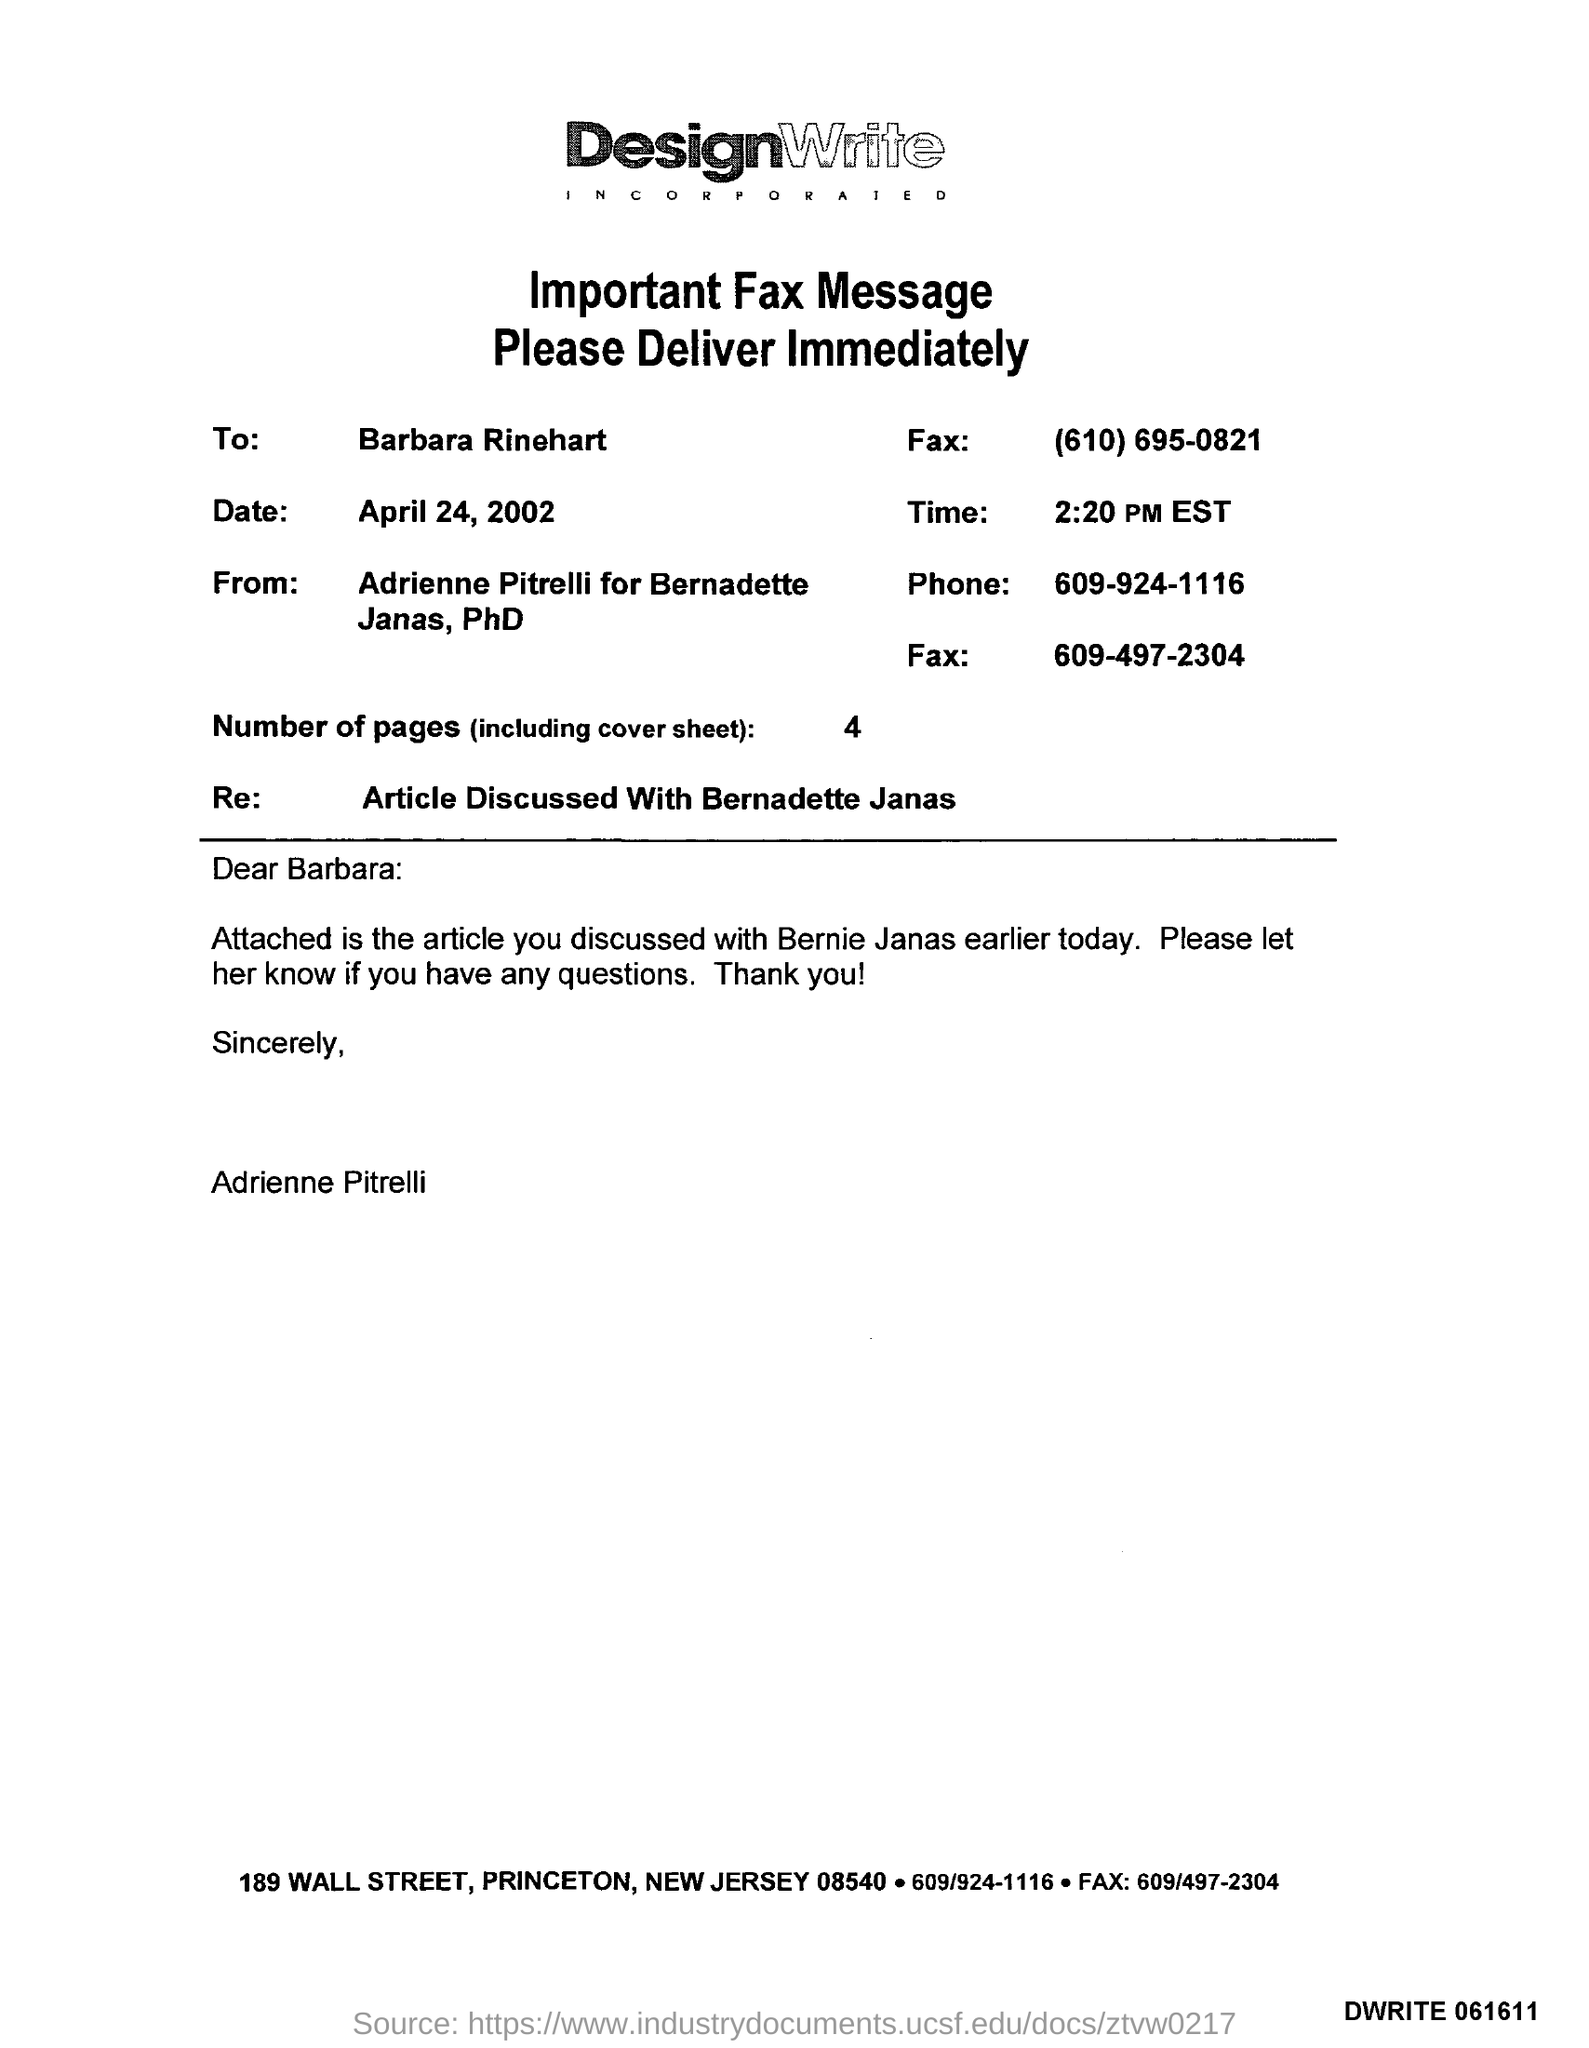Which company's fax message is this?
Your response must be concise. DesignWrite. To whom, the Fax is being sent?
Your answer should be compact. Barbara Rinehart. What is the date mentioned in the fax?
Your answer should be compact. April 24, 2002. What is the time mentioned in the fax?
Ensure brevity in your answer.  2:20 PM EST. How many pages are there in the fax including cover sheet?
Provide a short and direct response. 4. 